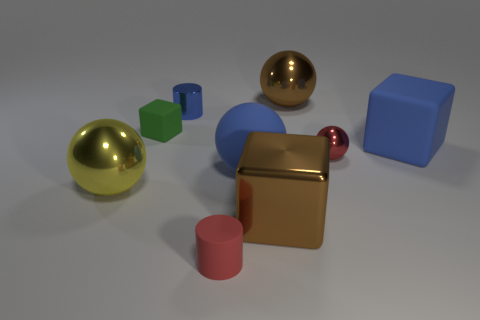There is a brown shiny object that is behind the tiny block behind the large ball to the left of the red rubber object; what is its size?
Your response must be concise. Large. What color is the small cylinder that is in front of the small shiny thing that is to the right of the tiny red matte thing?
Offer a very short reply. Red. There is a brown thing that is the same shape as the green object; what material is it?
Keep it short and to the point. Metal. Are there any other things that have the same material as the yellow object?
Your answer should be very brief. Yes. There is a big yellow metallic object; are there any tiny matte cubes in front of it?
Make the answer very short. No. What number of tiny things are there?
Your answer should be compact. 4. There is a matte block in front of the tiny green thing; how many large blocks are to the left of it?
Your response must be concise. 1. There is a rubber cylinder; is it the same color as the cube in front of the blue matte cube?
Ensure brevity in your answer.  No. What number of big matte things have the same shape as the yellow metal object?
Give a very brief answer. 1. What is the tiny cylinder in front of the yellow object made of?
Offer a terse response. Rubber. 